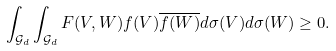<formula> <loc_0><loc_0><loc_500><loc_500>\int _ { \mathcal { G } _ { d } } \int _ { \mathcal { G } _ { d } } F ( V , W ) f ( V ) \overline { f ( W ) } d \sigma ( V ) d \sigma ( W ) \geq 0 .</formula> 